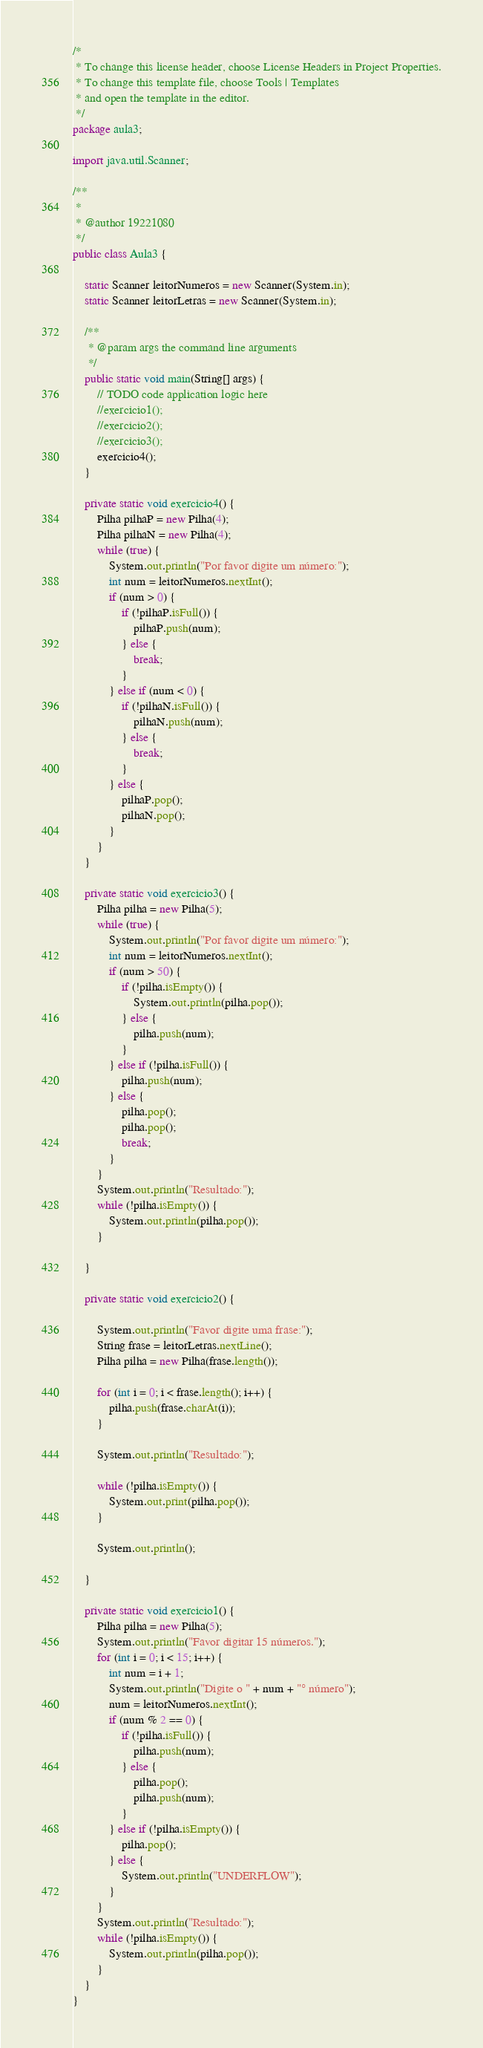<code> <loc_0><loc_0><loc_500><loc_500><_Java_>/*
 * To change this license header, choose License Headers in Project Properties.
 * To change this template file, choose Tools | Templates
 * and open the template in the editor.
 */
package aula3;

import java.util.Scanner;

/**
 *
 * @author 19221080
 */
public class Aula3 {

    static Scanner leitorNumeros = new Scanner(System.in);
    static Scanner leitorLetras = new Scanner(System.in);

    /**
     * @param args the command line arguments
     */
    public static void main(String[] args) {
        // TODO code application logic here
        //exercicio1();
        //exercicio2();
        //exercicio3();
        exercicio4();
    }

    private static void exercicio4() {
        Pilha pilhaP = new Pilha(4);
        Pilha pilhaN = new Pilha(4);
        while (true) {
            System.out.println("Por favor digite um número:");
            int num = leitorNumeros.nextInt();
            if (num > 0) {
                if (!pilhaP.isFull()) {
                    pilhaP.push(num);
                } else {
                    break;
                }
            } else if (num < 0) {
                if (!pilhaN.isFull()) {
                    pilhaN.push(num);
                } else {
                    break;
                }
            } else {
                pilhaP.pop();
                pilhaN.pop();
            }
        }
    }

    private static void exercicio3() {
        Pilha pilha = new Pilha(5);
        while (true) {
            System.out.println("Por favor digite um número:");
            int num = leitorNumeros.nextInt();
            if (num > 50) {
                if (!pilha.isEmpty()) {
                    System.out.println(pilha.pop());
                } else {
                    pilha.push(num);
                }
            } else if (!pilha.isFull()) {
                pilha.push(num);
            } else {
                pilha.pop();
                pilha.pop();
                break;
            }
        }
        System.out.println("Resultado:");
        while (!pilha.isEmpty()) {
            System.out.println(pilha.pop());
        }

    }

    private static void exercicio2() {

        System.out.println("Favor digite uma frase:");
        String frase = leitorLetras.nextLine();
        Pilha pilha = new Pilha(frase.length());

        for (int i = 0; i < frase.length(); i++) {
            pilha.push(frase.charAt(i));
        }

        System.out.println("Resultado:");

        while (!pilha.isEmpty()) {
            System.out.print(pilha.pop());
        }

        System.out.println();

    }

    private static void exercicio1() {
        Pilha pilha = new Pilha(5);
        System.out.println("Favor digitar 15 números.");
        for (int i = 0; i < 15; i++) {
            int num = i + 1;
            System.out.println("Digite o " + num + "° número");
            num = leitorNumeros.nextInt();
            if (num % 2 == 0) {
                if (!pilha.isFull()) {
                    pilha.push(num);
                } else {
                    pilha.pop();
                    pilha.push(num);
                }
            } else if (!pilha.isEmpty()) {
                pilha.pop();
            } else {
                System.out.println("UNDERFLOW");
            }
        }
        System.out.println("Resultado:");
        while (!pilha.isEmpty()) {
            System.out.println(pilha.pop());
        }
    }
}
</code> 